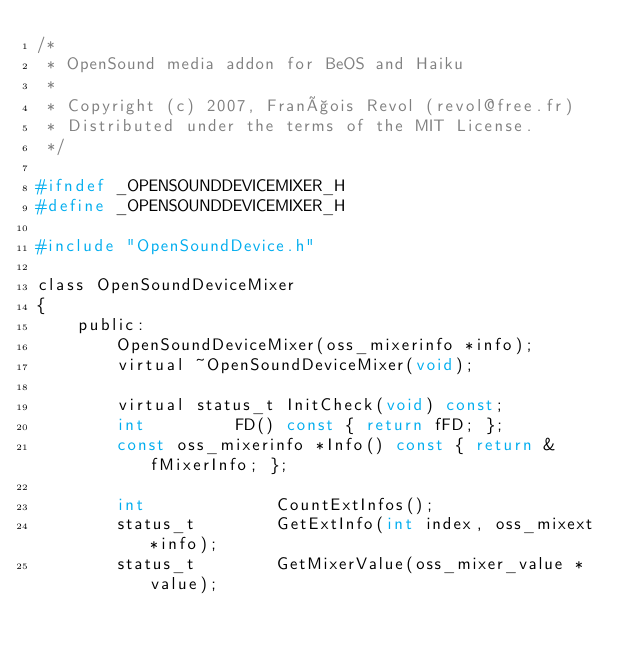<code> <loc_0><loc_0><loc_500><loc_500><_C_>/*
 * OpenSound media addon for BeOS and Haiku
 *
 * Copyright (c) 2007, François Revol (revol@free.fr)
 * Distributed under the terms of the MIT License.
 */

#ifndef _OPENSOUNDDEVICEMIXER_H
#define _OPENSOUNDDEVICEMIXER_H

#include "OpenSoundDevice.h"

class OpenSoundDeviceMixer
{
	public:
		OpenSoundDeviceMixer(oss_mixerinfo *info);
		virtual ~OpenSoundDeviceMixer(void);

		virtual status_t InitCheck(void) const;
		int			FD() const { return fFD; };
		const oss_mixerinfo *Info() const { return &fMixerInfo; };
		
		int				CountExtInfos();
		status_t		GetExtInfo(int index, oss_mixext *info);
		status_t		GetMixerValue(oss_mixer_value *value);</code> 